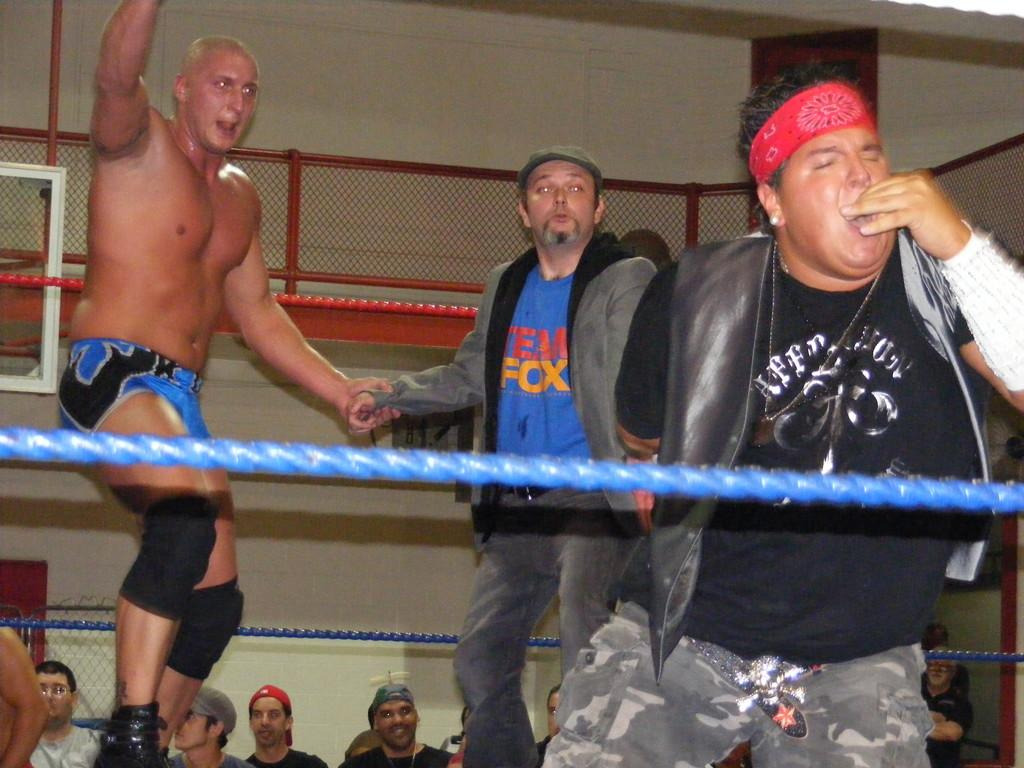Provide a one-sentence caption for the provided image. A man in the middle of a boxing ring with the words FOX on his shirt. 